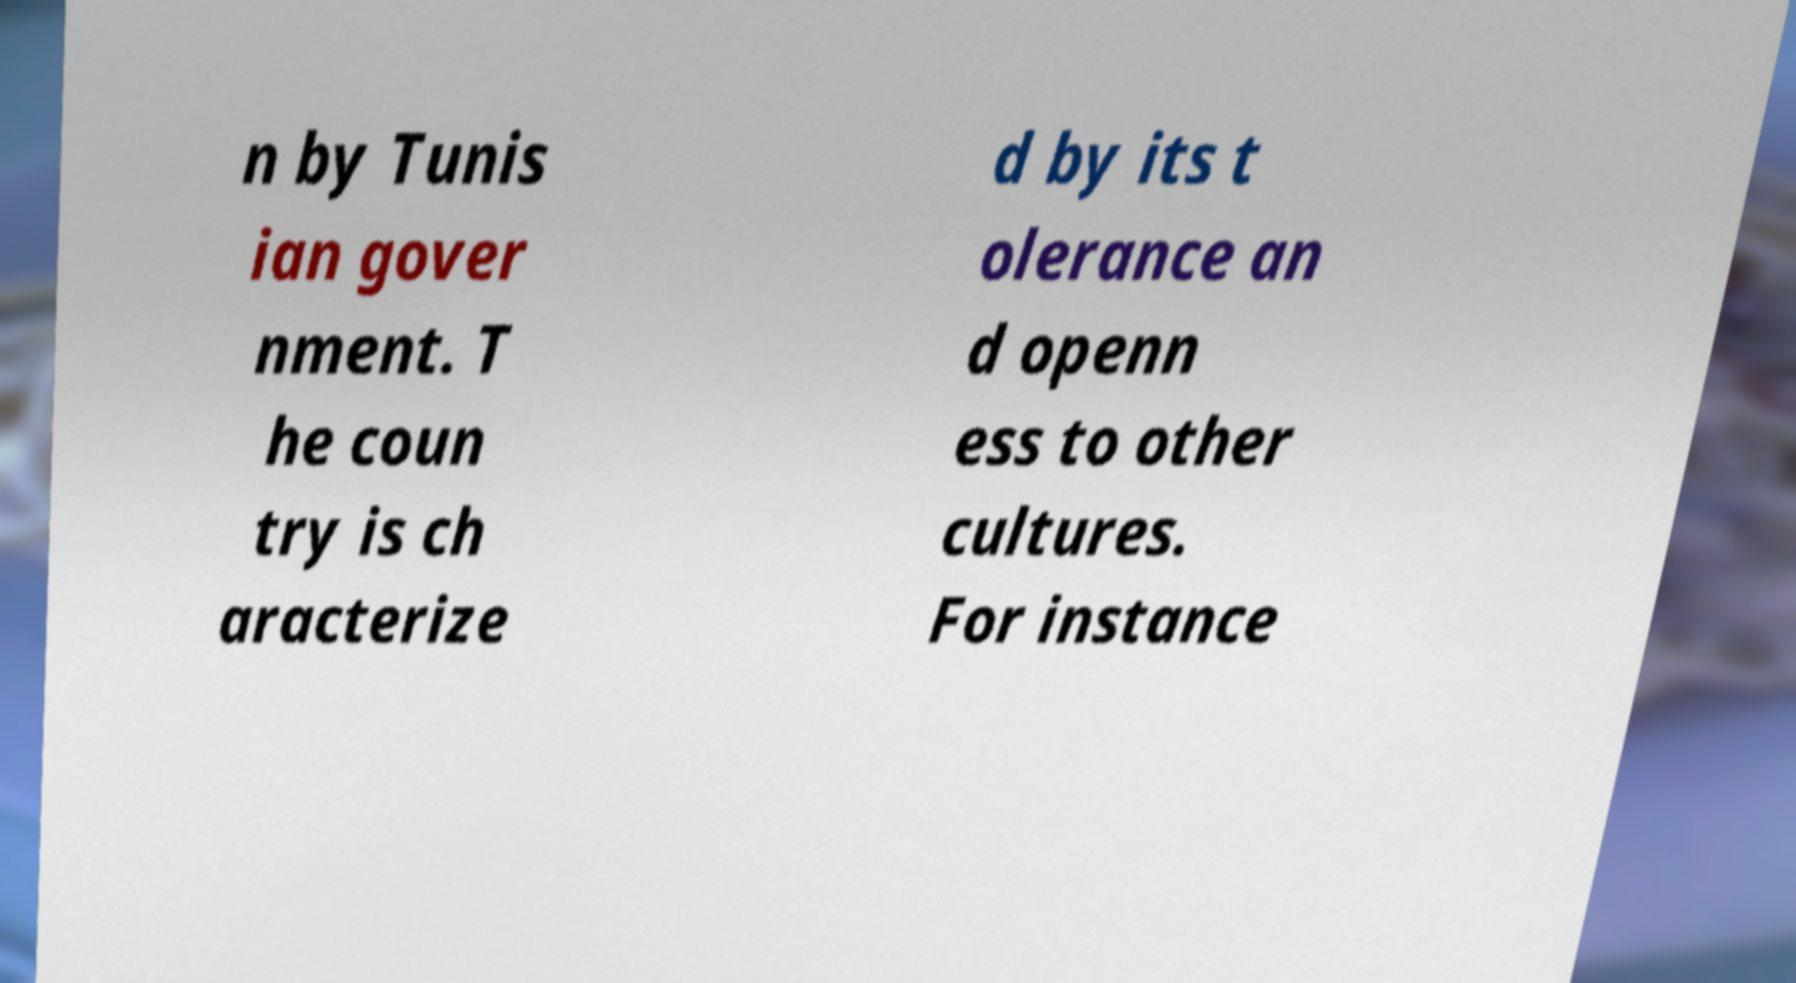Can you accurately transcribe the text from the provided image for me? n by Tunis ian gover nment. T he coun try is ch aracterize d by its t olerance an d openn ess to other cultures. For instance 